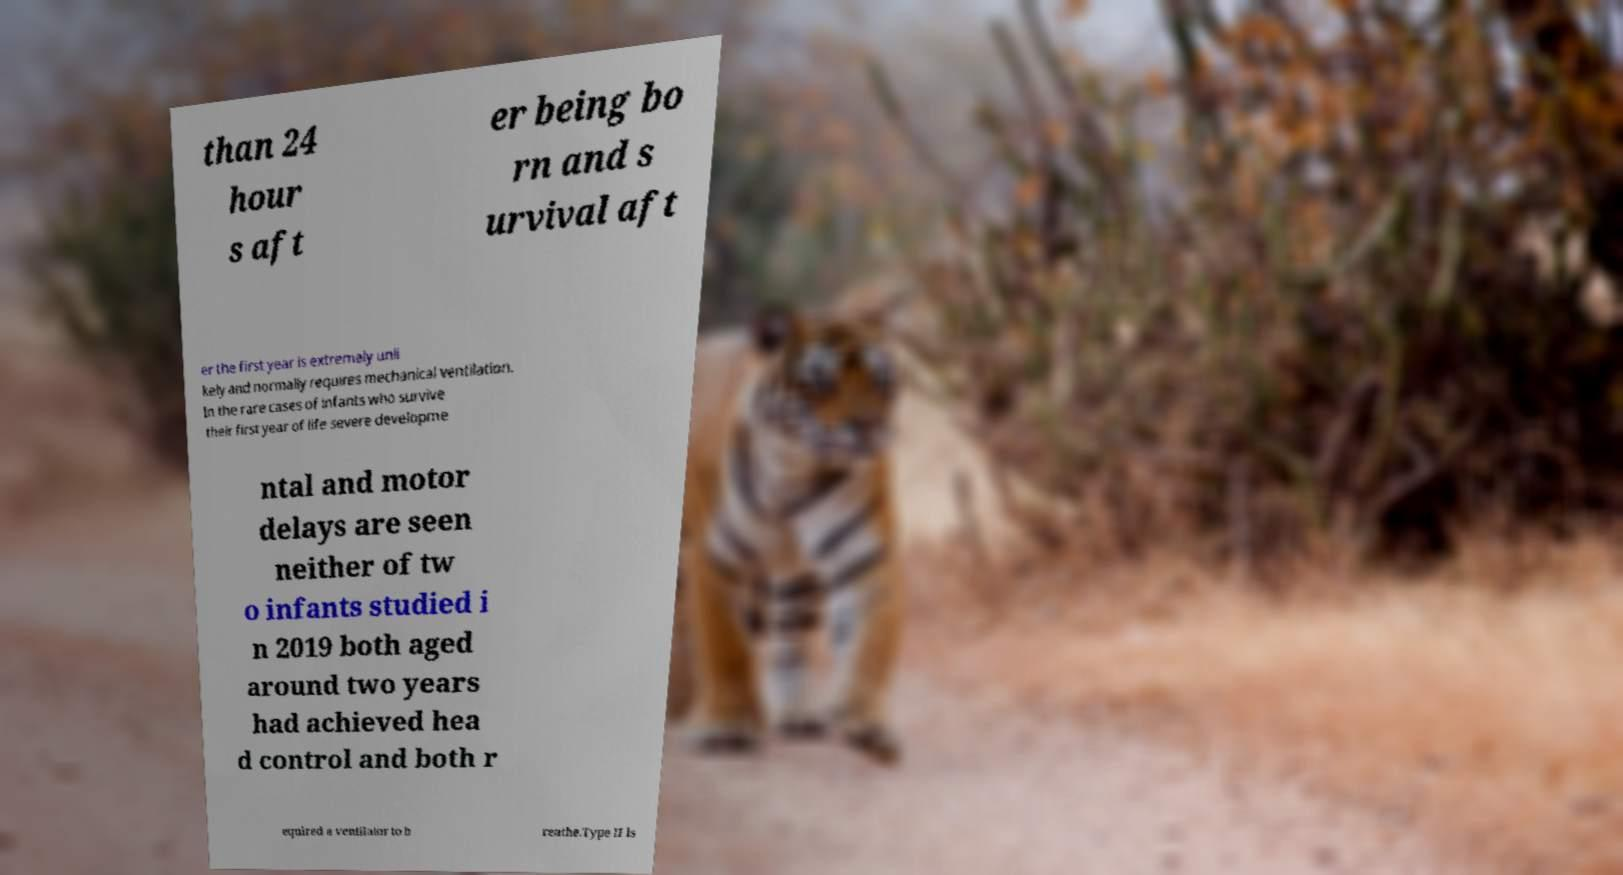For documentation purposes, I need the text within this image transcribed. Could you provide that? than 24 hour s aft er being bo rn and s urvival aft er the first year is extremely unli kely and normally requires mechanical ventilation. In the rare cases of infants who survive their first year of life severe developme ntal and motor delays are seen neither of tw o infants studied i n 2019 both aged around two years had achieved hea d control and both r equired a ventilator to b reathe.Type II is 